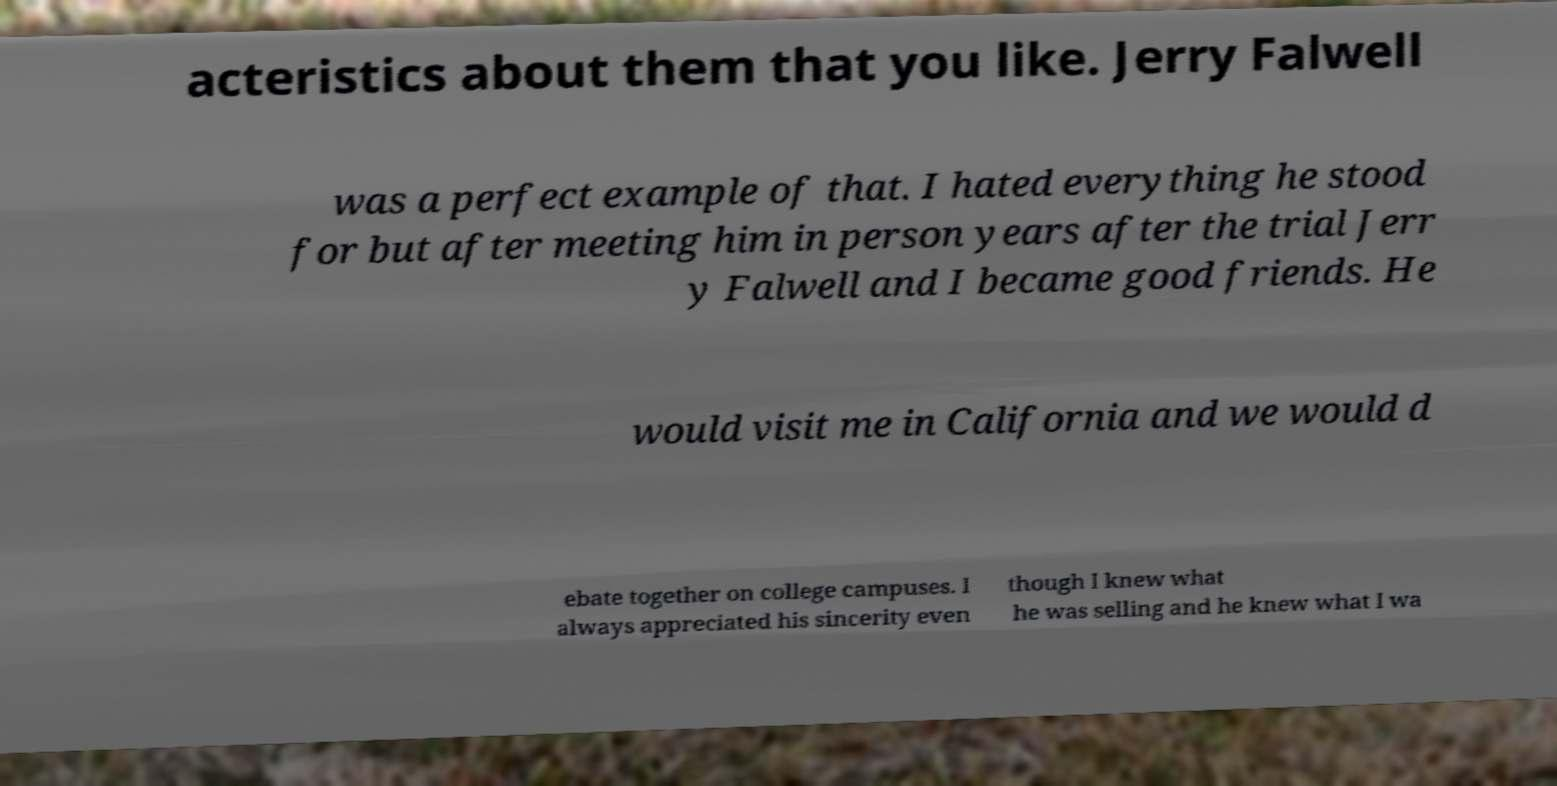Can you accurately transcribe the text from the provided image for me? acteristics about them that you like. Jerry Falwell was a perfect example of that. I hated everything he stood for but after meeting him in person years after the trial Jerr y Falwell and I became good friends. He would visit me in California and we would d ebate together on college campuses. I always appreciated his sincerity even though I knew what he was selling and he knew what I wa 